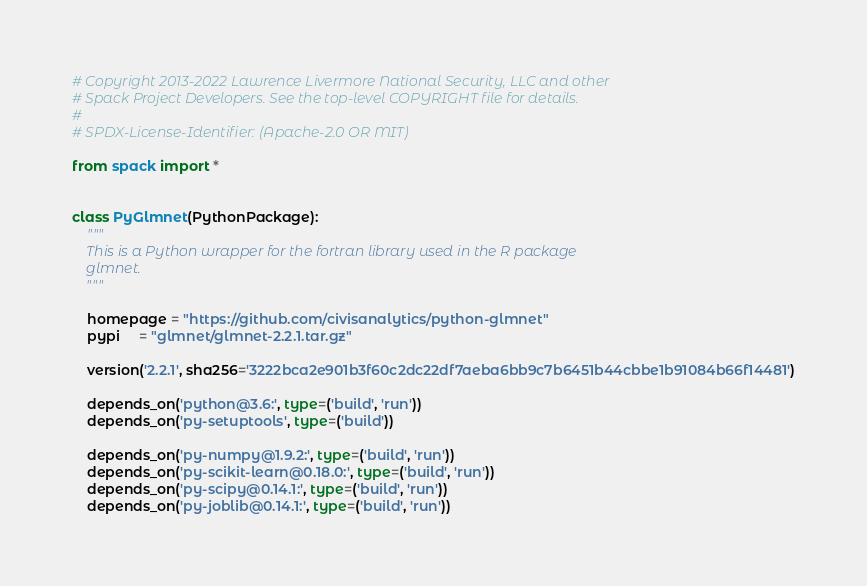Convert code to text. <code><loc_0><loc_0><loc_500><loc_500><_Python_># Copyright 2013-2022 Lawrence Livermore National Security, LLC and other
# Spack Project Developers. See the top-level COPYRIGHT file for details.
#
# SPDX-License-Identifier: (Apache-2.0 OR MIT)

from spack import *


class PyGlmnet(PythonPackage):
    """
    This is a Python wrapper for the fortran library used in the R package
    glmnet.
    """

    homepage = "https://github.com/civisanalytics/python-glmnet"
    pypi     = "glmnet/glmnet-2.2.1.tar.gz"

    version('2.2.1', sha256='3222bca2e901b3f60c2dc22df7aeba6bb9c7b6451b44cbbe1b91084b66f14481')

    depends_on('python@3.6:', type=('build', 'run'))
    depends_on('py-setuptools', type=('build'))

    depends_on('py-numpy@1.9.2:', type=('build', 'run'))
    depends_on('py-scikit-learn@0.18.0:', type=('build', 'run'))
    depends_on('py-scipy@0.14.1:', type=('build', 'run'))
    depends_on('py-joblib@0.14.1:', type=('build', 'run'))
</code> 